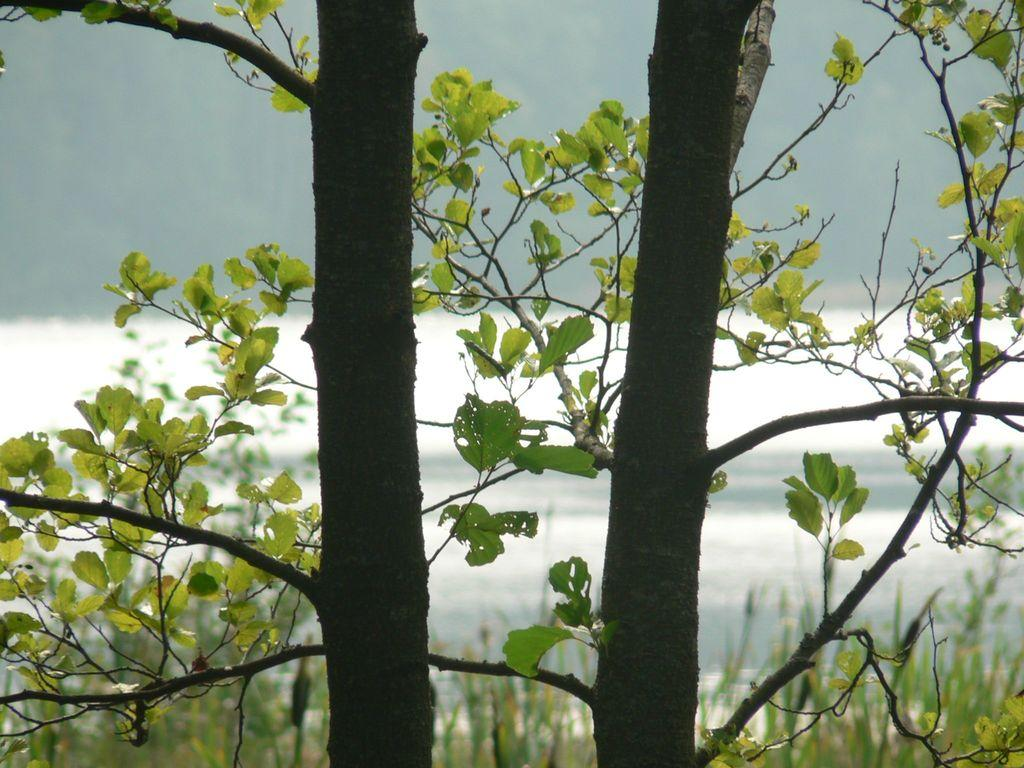What type of natural elements can be seen in the image? There are trees in the image. How would you describe the background of the image? The background of the image is blurred. Where is the mailbox located in the image? There is no mailbox present in the image. What type of water movement can be seen in the image? There are no waves or water movement visible in the image. 